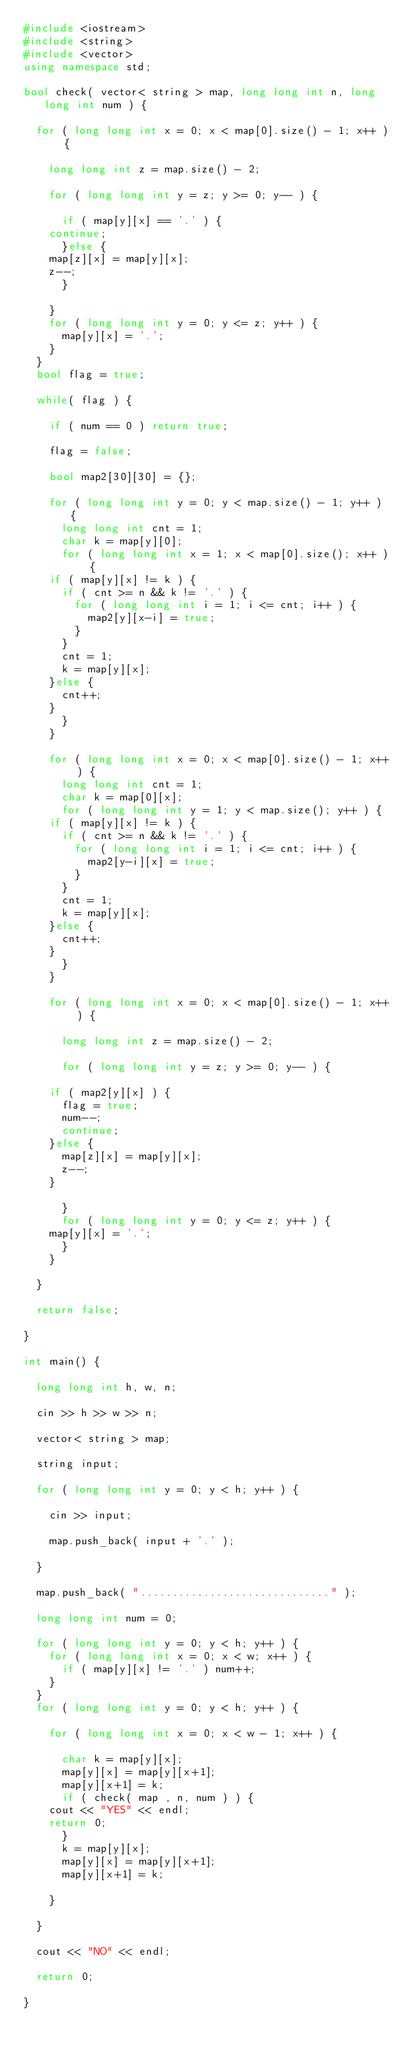Convert code to text. <code><loc_0><loc_0><loc_500><loc_500><_C++_>#include <iostream>
#include <string>
#include <vector>
using namespace std;

bool check( vector< string > map, long long int n, long long int num ) {

  for ( long long int x = 0; x < map[0].size() - 1; x++ ) {

    long long int z = map.size() - 2;

    for ( long long int y = z; y >= 0; y-- ) {

      if ( map[y][x] == '.' ) {
	continue;
      }else {
	map[z][x] = map[y][x];
	z--;
      }

    }
    for ( long long int y = 0; y <= z; y++ ) {
      map[y][x] = '.';
    }
  }
  bool flag = true;

  while( flag ) {

    if ( num == 0 ) return true;

    flag = false;

    bool map2[30][30] = {};

    for ( long long int y = 0; y < map.size() - 1; y++ ) {
      long long int cnt = 1;
      char k = map[y][0];
      for ( long long int x = 1; x < map[0].size(); x++ ) {
	if ( map[y][x] != k ) {
	  if ( cnt >= n && k != '.' ) {
	    for ( long long int i = 1; i <= cnt; i++ ) {
	      map2[y][x-i] = true;
	    }
	  }
	  cnt = 1;
	  k = map[y][x];
	}else {
	  cnt++;
	}
      }
    }

    for ( long long int x = 0; x < map[0].size() - 1; x++ ) {
      long long int cnt = 1;
      char k = map[0][x];
      for ( long long int y = 1; y < map.size(); y++ ) {
	if ( map[y][x] != k ) {
	  if ( cnt >= n && k != '.' ) {
	    for ( long long int i = 1; i <= cnt; i++ ) {
	      map2[y-i][x] = true;
	    }
	  }
	  cnt = 1;
	  k = map[y][x];
	}else {
	  cnt++;
	}
      }
    }

    for ( long long int x = 0; x < map[0].size() - 1; x++ ) {

      long long int z = map.size() - 2;

      for ( long long int y = z; y >= 0; y-- ) {

	if ( map2[y][x] ) {
	  flag = true;
	  num--;
	  continue;
	}else {
	  map[z][x] = map[y][x];
	  z--;
	}

      }
      for ( long long int y = 0; y <= z; y++ ) {
	map[y][x] = '.';
      }
    }

  }

  return false;

}

int main() {

  long long int h, w, n;

  cin >> h >> w >> n;

  vector< string > map;

  string input;

  for ( long long int y = 0; y < h; y++ ) {

    cin >> input;

    map.push_back( input + '.' );

  }

  map.push_back( ".............................." );

  long long int num = 0;

  for ( long long int y = 0; y < h; y++ ) {
    for ( long long int x = 0; x < w; x++ ) {
      if ( map[y][x] != '.' ) num++;
    }
  }
  for ( long long int y = 0; y < h; y++ ) {

    for ( long long int x = 0; x < w - 1; x++ ) {

      char k = map[y][x];
      map[y][x] = map[y][x+1];
      map[y][x+1] = k;
      if ( check( map , n, num ) ) {
	cout << "YES" << endl;
	return 0;
      }
      k = map[y][x];
      map[y][x] = map[y][x+1];
      map[y][x+1] = k;

    }

  }

  cout << "NO" << endl;

  return 0;

}</code> 